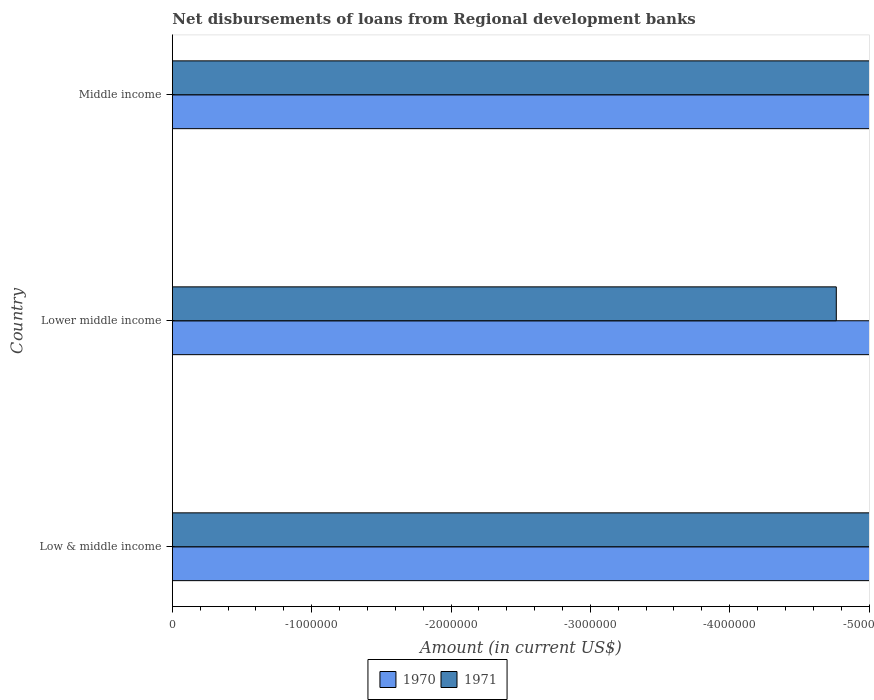How many bars are there on the 1st tick from the bottom?
Make the answer very short. 0. Across all countries, what is the minimum amount of disbursements of loans from regional development banks in 1970?
Offer a terse response. 0. In how many countries, is the amount of disbursements of loans from regional development banks in 1970 greater than the average amount of disbursements of loans from regional development banks in 1970 taken over all countries?
Ensure brevity in your answer.  0. How many countries are there in the graph?
Ensure brevity in your answer.  3. Where does the legend appear in the graph?
Your response must be concise. Bottom center. How many legend labels are there?
Ensure brevity in your answer.  2. What is the title of the graph?
Offer a terse response. Net disbursements of loans from Regional development banks. Does "2008" appear as one of the legend labels in the graph?
Make the answer very short. No. What is the label or title of the Y-axis?
Offer a very short reply. Country. What is the Amount (in current US$) of 1970 in Low & middle income?
Make the answer very short. 0. What is the Amount (in current US$) of 1971 in Low & middle income?
Your answer should be very brief. 0. What is the Amount (in current US$) of 1970 in Lower middle income?
Your answer should be very brief. 0. What is the Amount (in current US$) in 1971 in Middle income?
Your answer should be very brief. 0. What is the total Amount (in current US$) in 1970 in the graph?
Offer a terse response. 0. What is the average Amount (in current US$) in 1971 per country?
Your answer should be very brief. 0. 